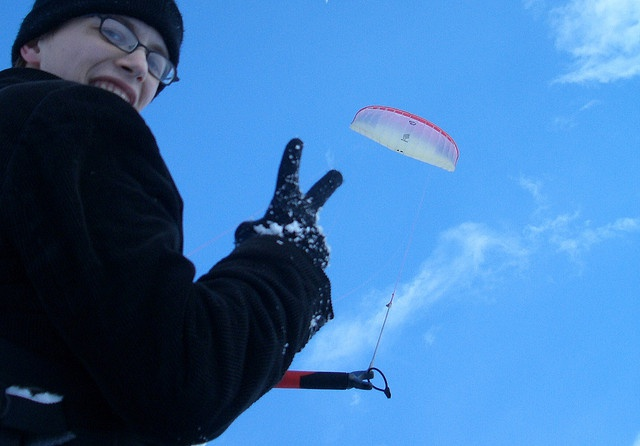Describe the objects in this image and their specific colors. I can see people in gray, black, and navy tones and kite in gray, darkgray, lightblue, and violet tones in this image. 